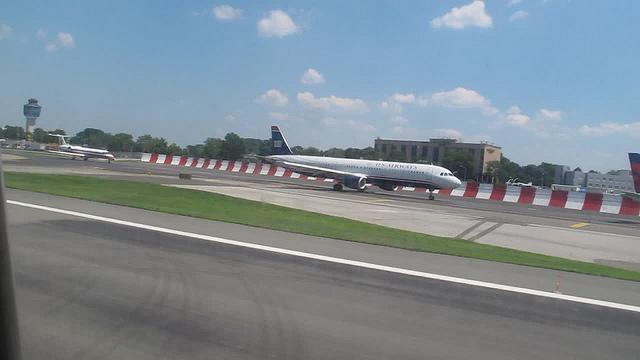How many airplanes are on the runway?
Give a very brief answer. 2. 